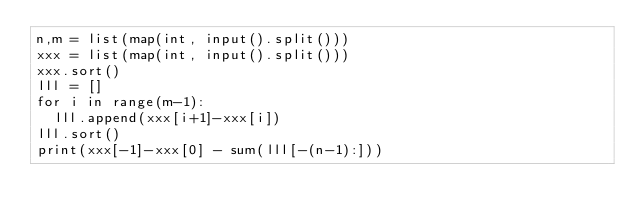Convert code to text. <code><loc_0><loc_0><loc_500><loc_500><_Python_>n,m = list(map(int, input().split()))
xxx = list(map(int, input().split()))
xxx.sort()
lll = []
for i in range(m-1):
  lll.append(xxx[i+1]-xxx[i])
lll.sort()
print(xxx[-1]-xxx[0] - sum(lll[-(n-1):]))</code> 